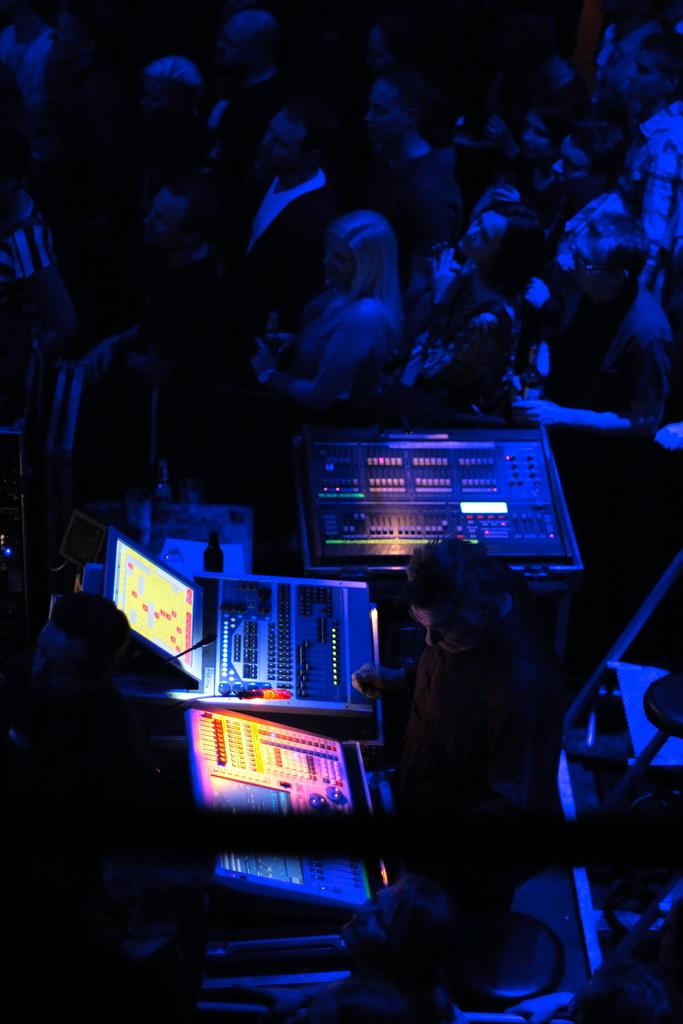What is the main subject of the image? The main subject of the image is a group of people. What objects can be seen in the image related to communication or performance? There is a screen and a microphone (mic) in the image. What type of equipment is present that is typically used in music or performance? There are musical instruments in the image. What type of flesh can be seen on the screen in the image? There is no flesh visible on the screen in the image. The screen is likely displaying information or visuals related to the performance or event. 